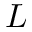<formula> <loc_0><loc_0><loc_500><loc_500>L</formula> 